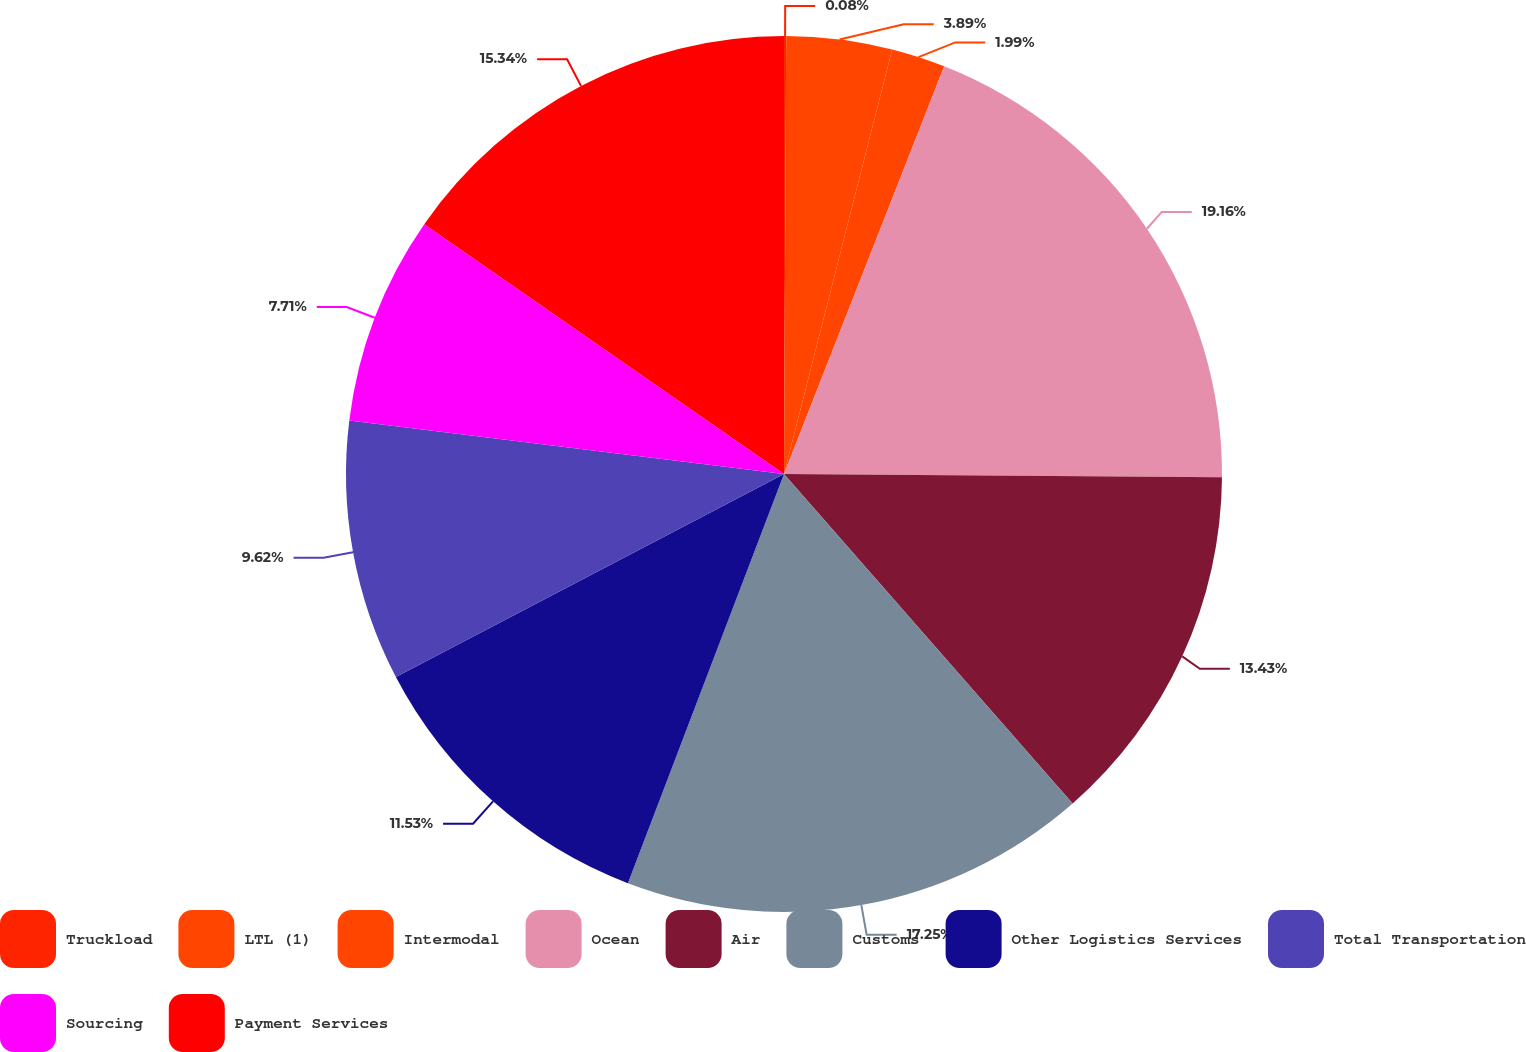<chart> <loc_0><loc_0><loc_500><loc_500><pie_chart><fcel>Truckload<fcel>LTL (1)<fcel>Intermodal<fcel>Ocean<fcel>Air<fcel>Customs<fcel>Other Logistics Services<fcel>Total Transportation<fcel>Sourcing<fcel>Payment Services<nl><fcel>0.08%<fcel>3.89%<fcel>1.99%<fcel>19.16%<fcel>13.43%<fcel>17.25%<fcel>11.53%<fcel>9.62%<fcel>7.71%<fcel>15.34%<nl></chart> 